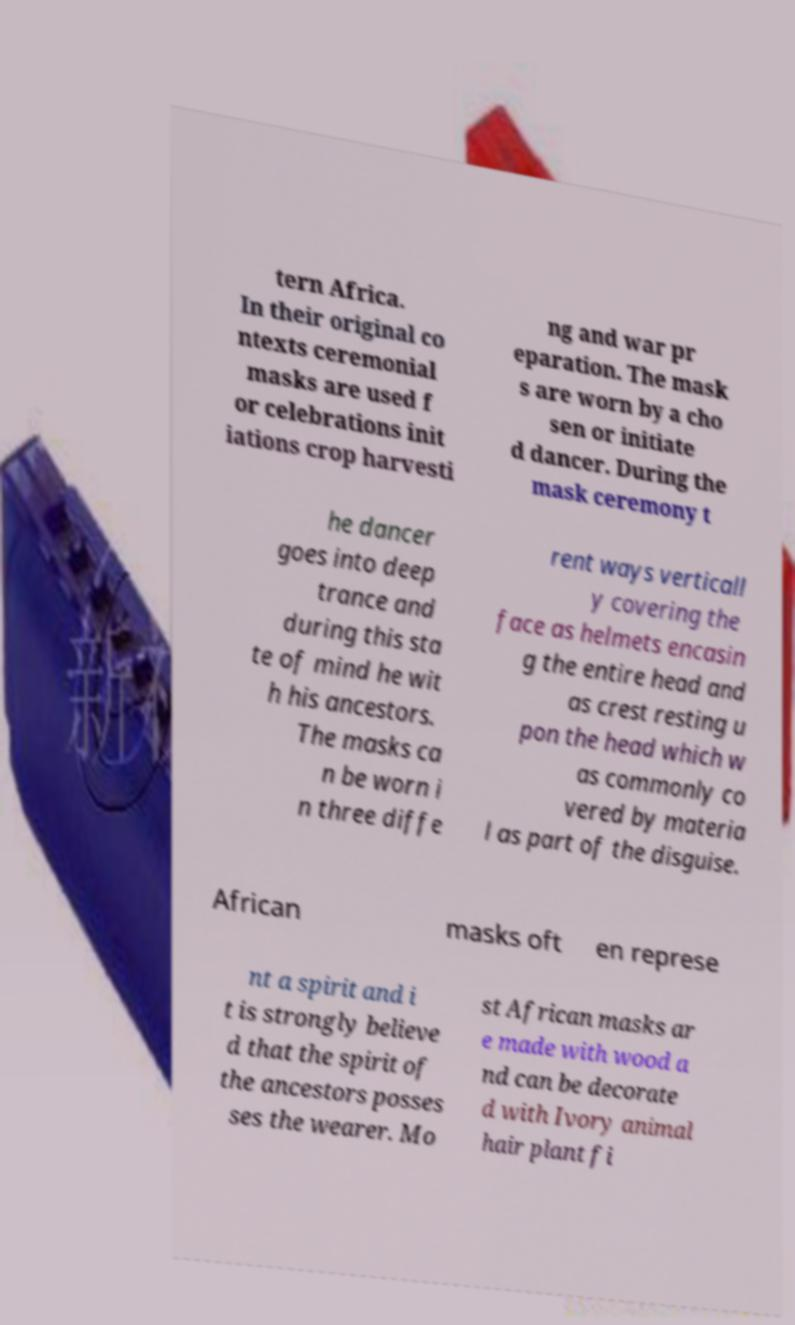Please read and relay the text visible in this image. What does it say? tern Africa. In their original co ntexts ceremonial masks are used f or celebrations init iations crop harvesti ng and war pr eparation. The mask s are worn by a cho sen or initiate d dancer. During the mask ceremony t he dancer goes into deep trance and during this sta te of mind he wit h his ancestors. The masks ca n be worn i n three diffe rent ways verticall y covering the face as helmets encasin g the entire head and as crest resting u pon the head which w as commonly co vered by materia l as part of the disguise. African masks oft en represe nt a spirit and i t is strongly believe d that the spirit of the ancestors posses ses the wearer. Mo st African masks ar e made with wood a nd can be decorate d with Ivory animal hair plant fi 